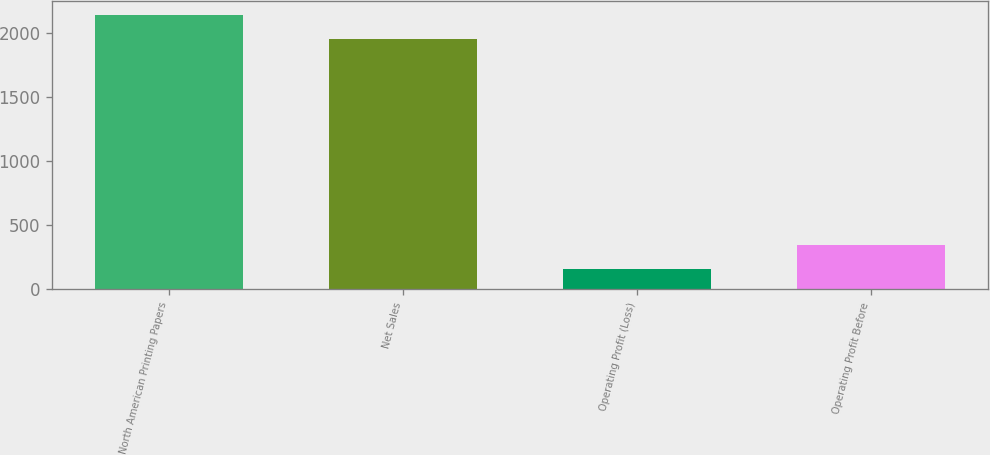Convert chart to OTSL. <chart><loc_0><loc_0><loc_500><loc_500><bar_chart><fcel>North American Printing Papers<fcel>Net Sales<fcel>Operating Profit (Loss)<fcel>Operating Profit Before<nl><fcel>2141.8<fcel>1956<fcel>160<fcel>345.8<nl></chart> 